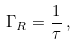<formula> <loc_0><loc_0><loc_500><loc_500>\Gamma _ { R } = \frac { 1 } { \tau } \, ,</formula> 